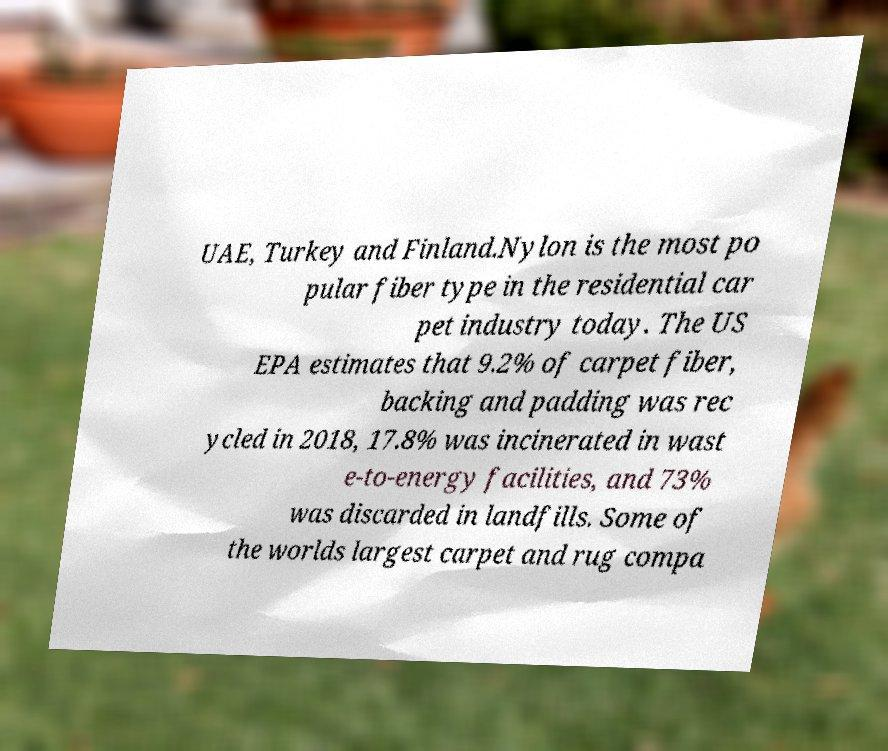Can you accurately transcribe the text from the provided image for me? UAE, Turkey and Finland.Nylon is the most po pular fiber type in the residential car pet industry today. The US EPA estimates that 9.2% of carpet fiber, backing and padding was rec ycled in 2018, 17.8% was incinerated in wast e-to-energy facilities, and 73% was discarded in landfills. Some of the worlds largest carpet and rug compa 